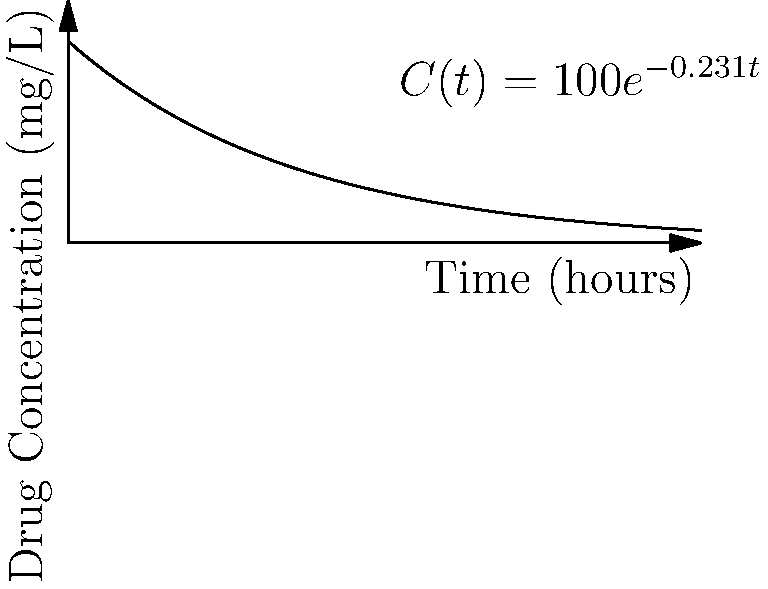The graph shows the concentration of a drug in a patient's bloodstream over time. The concentration $C(t)$ in mg/L at time $t$ in hours is given by the function $C(t) = 100e^{-0.231t}$. Using the graph and the given function, determine the half-life of the drug to the nearest tenth of an hour. To find the half-life of the drug, we need to determine the time it takes for the concentration to reduce to half of its initial value. Let's approach this step-by-step:

1) The initial concentration (at $t=0$) is 100 mg/L.

2) We need to find $t$ when $C(t) = 50$ mg/L (half of the initial concentration).

3) Substituting these values into the equation:
   $50 = 100e^{-0.231t}$

4) Dividing both sides by 100:
   $0.5 = e^{-0.231t}$

5) Taking the natural logarithm of both sides:
   $\ln(0.5) = -0.231t$

6) Solving for $t$:
   $t = \frac{\ln(0.5)}{-0.231} = \frac{-0.693}{-0.231} \approx 3.0$ hours

Therefore, the half-life of the drug is approximately 3.0 hours.

We can verify this on the graph: starting at 100 mg/L, after about 3 hours, the concentration has decreased to around 50 mg/L.
Answer: 3.0 hours 